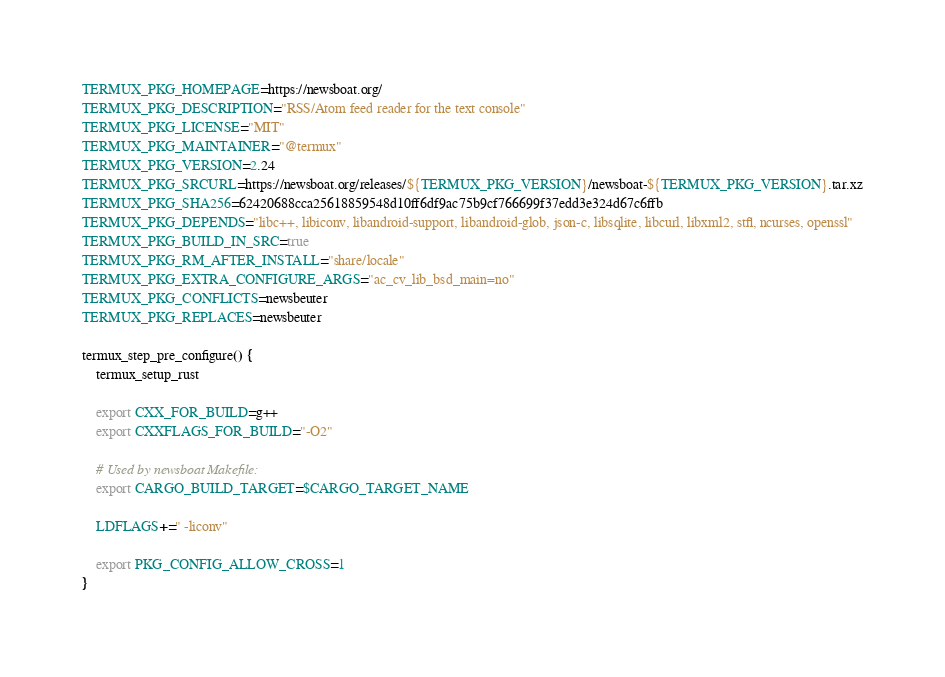Convert code to text. <code><loc_0><loc_0><loc_500><loc_500><_Bash_>TERMUX_PKG_HOMEPAGE=https://newsboat.org/
TERMUX_PKG_DESCRIPTION="RSS/Atom feed reader for the text console"
TERMUX_PKG_LICENSE="MIT"
TERMUX_PKG_MAINTAINER="@termux"
TERMUX_PKG_VERSION=2.24
TERMUX_PKG_SRCURL=https://newsboat.org/releases/${TERMUX_PKG_VERSION}/newsboat-${TERMUX_PKG_VERSION}.tar.xz
TERMUX_PKG_SHA256=62420688cca25618859548d10ff6df9ac75b9cf766699f37edd3e324d67c6ffb
TERMUX_PKG_DEPENDS="libc++, libiconv, libandroid-support, libandroid-glob, json-c, libsqlite, libcurl, libxml2, stfl, ncurses, openssl"
TERMUX_PKG_BUILD_IN_SRC=true
TERMUX_PKG_RM_AFTER_INSTALL="share/locale"
TERMUX_PKG_EXTRA_CONFIGURE_ARGS="ac_cv_lib_bsd_main=no"
TERMUX_PKG_CONFLICTS=newsbeuter
TERMUX_PKG_REPLACES=newsbeuter

termux_step_pre_configure() {
	termux_setup_rust

	export CXX_FOR_BUILD=g++
	export CXXFLAGS_FOR_BUILD="-O2"

	# Used by newsboat Makefile:
	export CARGO_BUILD_TARGET=$CARGO_TARGET_NAME

	LDFLAGS+=" -liconv"

	export PKG_CONFIG_ALLOW_CROSS=1
}
</code> 